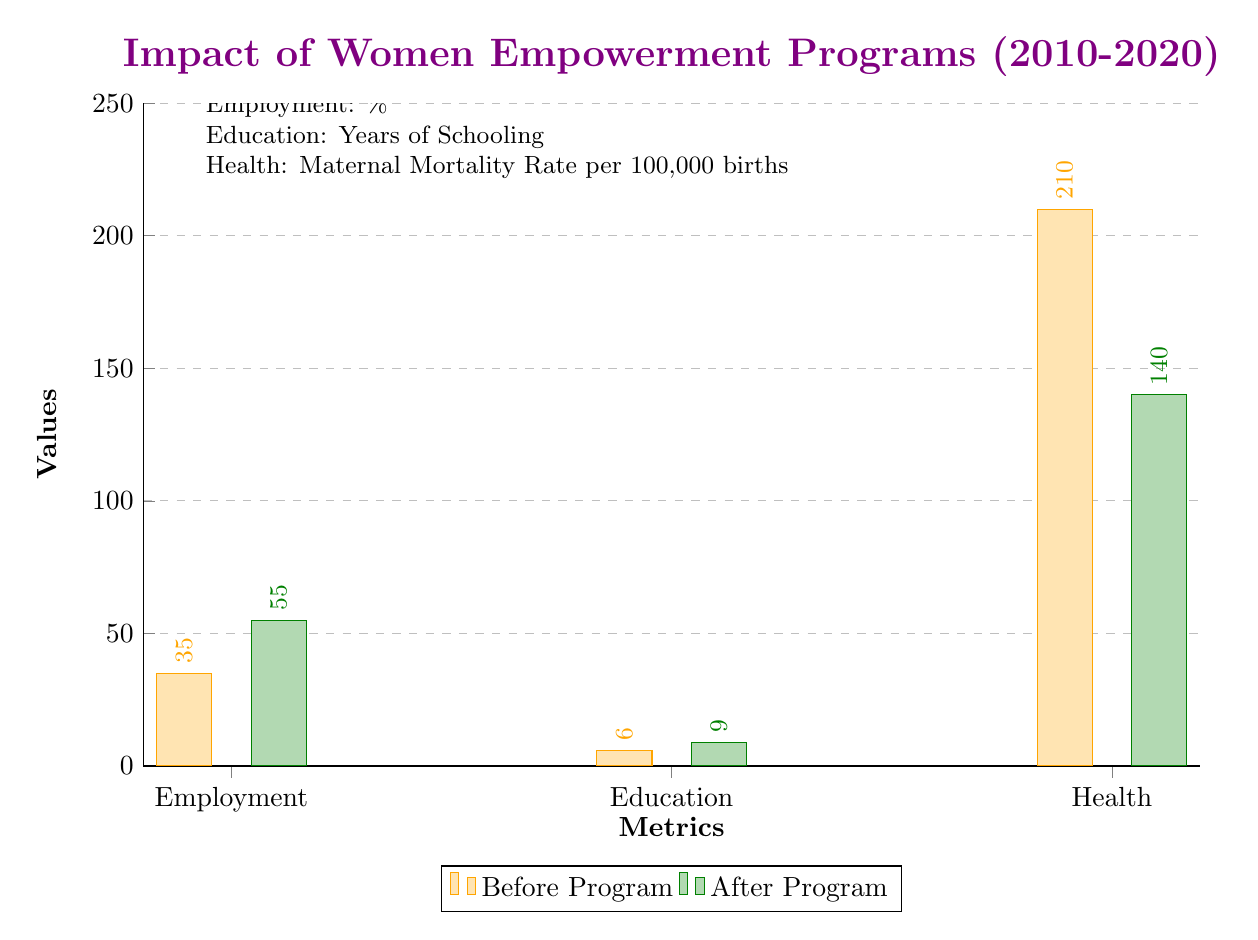What was the employment percentage before the program? The diagram indicates that the employment percentage before the program was 35. This value can be found by looking at the first bar under the "Employment" category in the left section of the bar chart.
Answer: 35 What was the education level after the program? The education level after the program is shown as 9 years of schooling. This corresponds to the second bar under the "Education" category in the right section of the diagram.
Answer: 9 What is the maternal mortality rate before the program? The maternal mortality rate before the program is represented as 210 per 100,000 births. This information is found in the left section of the Health category in the diagram.
Answer: 210 Which category saw the largest increase after the program? The Employment category saw the largest increase, moving from 35% before the program to 55% after the program. This indicates a gain of 20 percentage points, which is the most significant increase among the three metrics.
Answer: Employment What is the total difference in health metrics before and after the program? To find the total difference, we take the maternal mortality rate before the program (210) and compare it to the after figure (140). The subtraction gives a difference of 70 fewer deaths per 100,000 births after the program.
Answer: 70 How did the education level change after the program compared to before? The education level before the program was 6 years, and after the program, it increased to 9 years. The change can be calculated by subtracting the before value from the after value, resulting in an increase of 3 years.
Answer: 3 years What is the highest value in the diagram? The highest value in the diagram is the maternal mortality rate before the program, which is 210. This is the largest data point when comparing all categories and their respective before and after values.
Answer: 210 What is the value increase in employment? The increase in employment can be calculated by taking the after value (55) and subtracting the before value (35). This results in an increase of 20 percentage points in employment due to the program.
Answer: 20 What color represents the status after the program? The color representing the status after the program is green. This is visually indicated in the diagram, where the bars after the program are filled with a green shade.
Answer: Green 